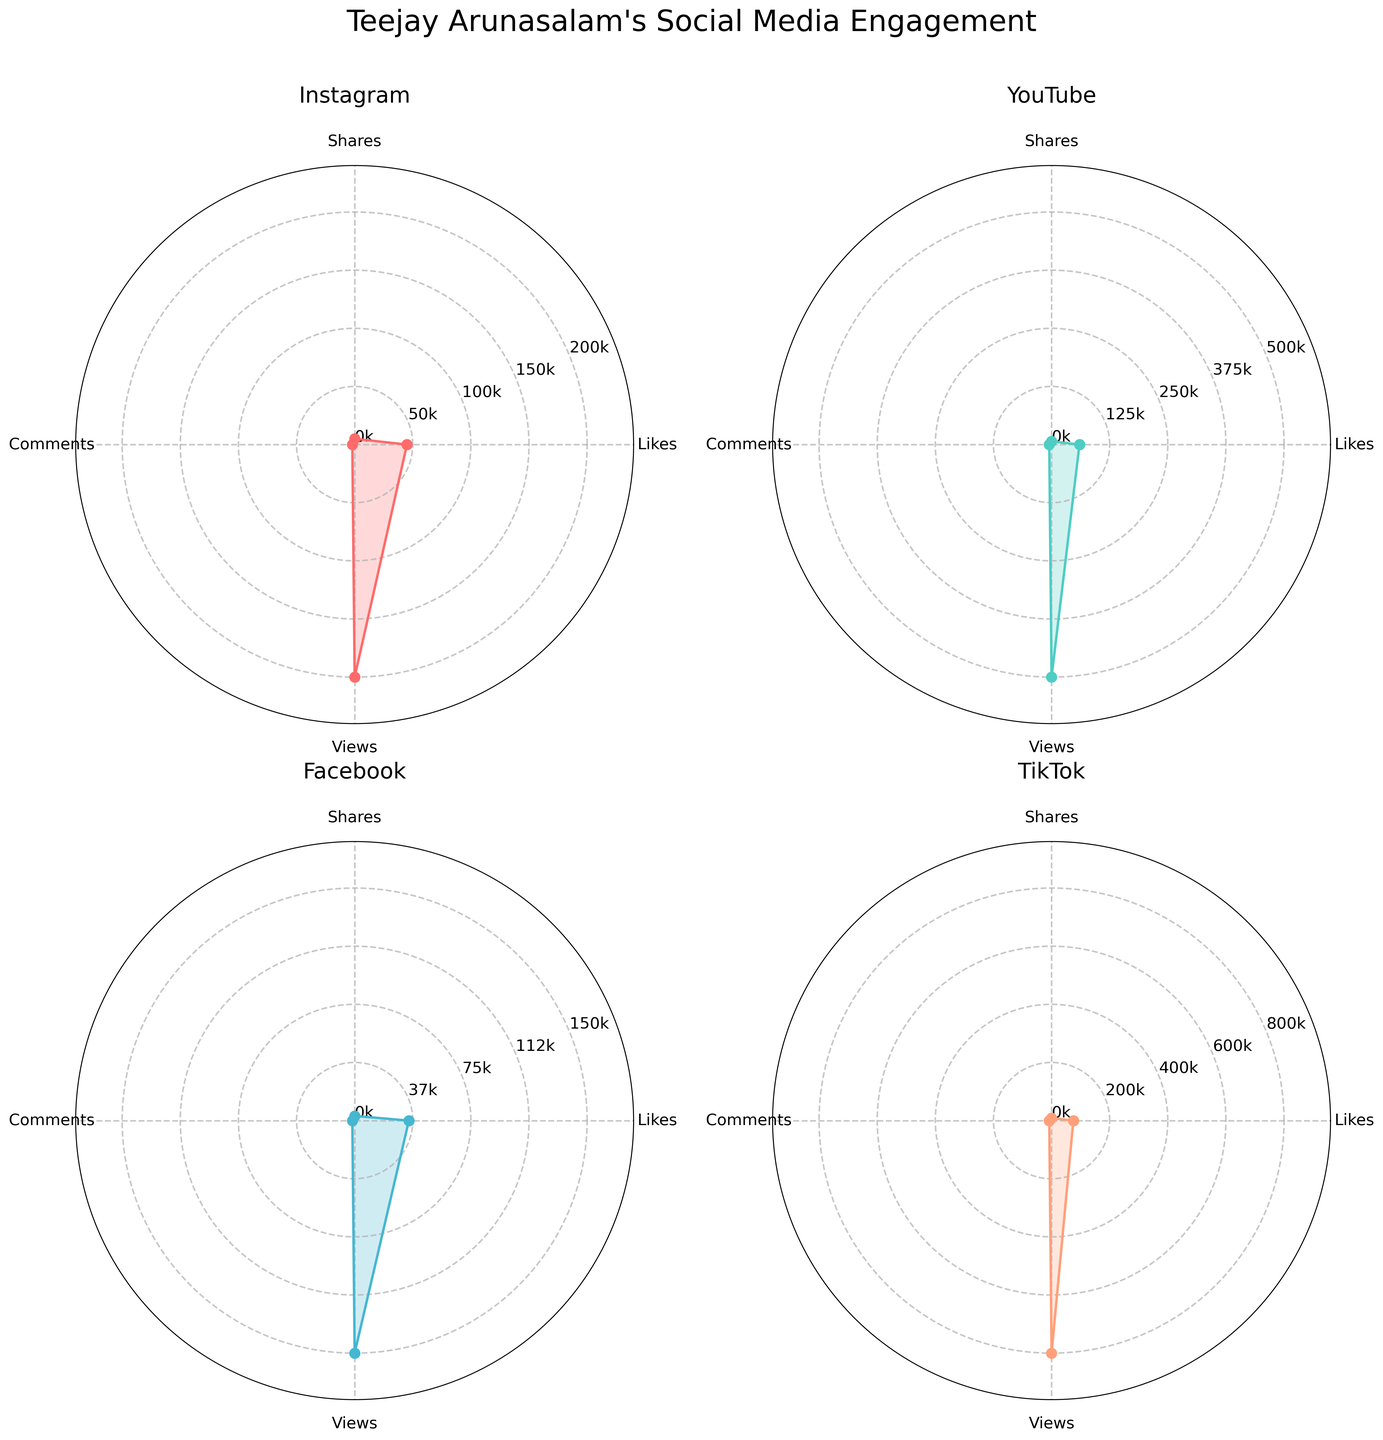What is the title of the figure? The title is generally found at the top of the figure. Reading the given information, the title of the figure is "Teejay Arunasalam's Social Media Engagement".
Answer: Teejay Arunasalam's Social Media Engagement What engagement metric has the highest value on Facebook? By looking at the radar chart for Facebook, the highest value is at the point furthest from the center. According to the data, this corresponds to the Views metric.
Answer: Views Which platform has the highest number of comments? To find this, identify the Comments section in each radar chart and check which platform has the furthest point from the center for Comments. TikTok has the highest number of comments as its value for Comments is 8000.
Answer: TikTok Compare the number of Likes between Instagram and YouTube. Which one has more? The number of Likes for Instagram is 45000, and for YouTube, it is 60000. Comparing these values, YouTube has more Likes than Instagram.
Answer: YouTube What is the sum of Shares and Likes on TikTok? From the radar chart for TikTok, the value for Shares is 9000 and for Likes is 75000. Summing these values: 9000 + 75000 = 84000.
Answer: 84000 How does the engagement in terms of Views compare between YouTube and Instagram? From the radar charts, YouTube has 500000 Views, and Instagram has 200000 Views. YouTube has considerably more Views than Instagram.
Answer: YouTube has more views What is the average number of Shares across all platforms? Summing the Shares from all platforms: 5000 (Instagram) + 7000 (YouTube) + 3000 (Facebook) + 9000 (TikTok) = 24000. Dividing by the number of platforms (4): 24000 / 4 = 6000.
Answer: 6000 Which platform has the smallest number of Comments? By looking at the radar charts, the smallest number of Comments is on Facebook, with 1500 Comments.
Answer: Facebook By what percentage do TikTok’s Likes exceed Facebook’s Likes? Facebook has 35000 Likes, and TikTok has 75000 Likes. To find the percentage increase: (75000 - 35000) / 35000 * 100% = 114.29%.
Answer: 114.29% What is the feature common to the subplots of all platforms? Observing the radar charts, each subplot represents one platform and all have the same metrics (Likes, Shares, Comments, Views) arranged around them.
Answer: Same metrics 